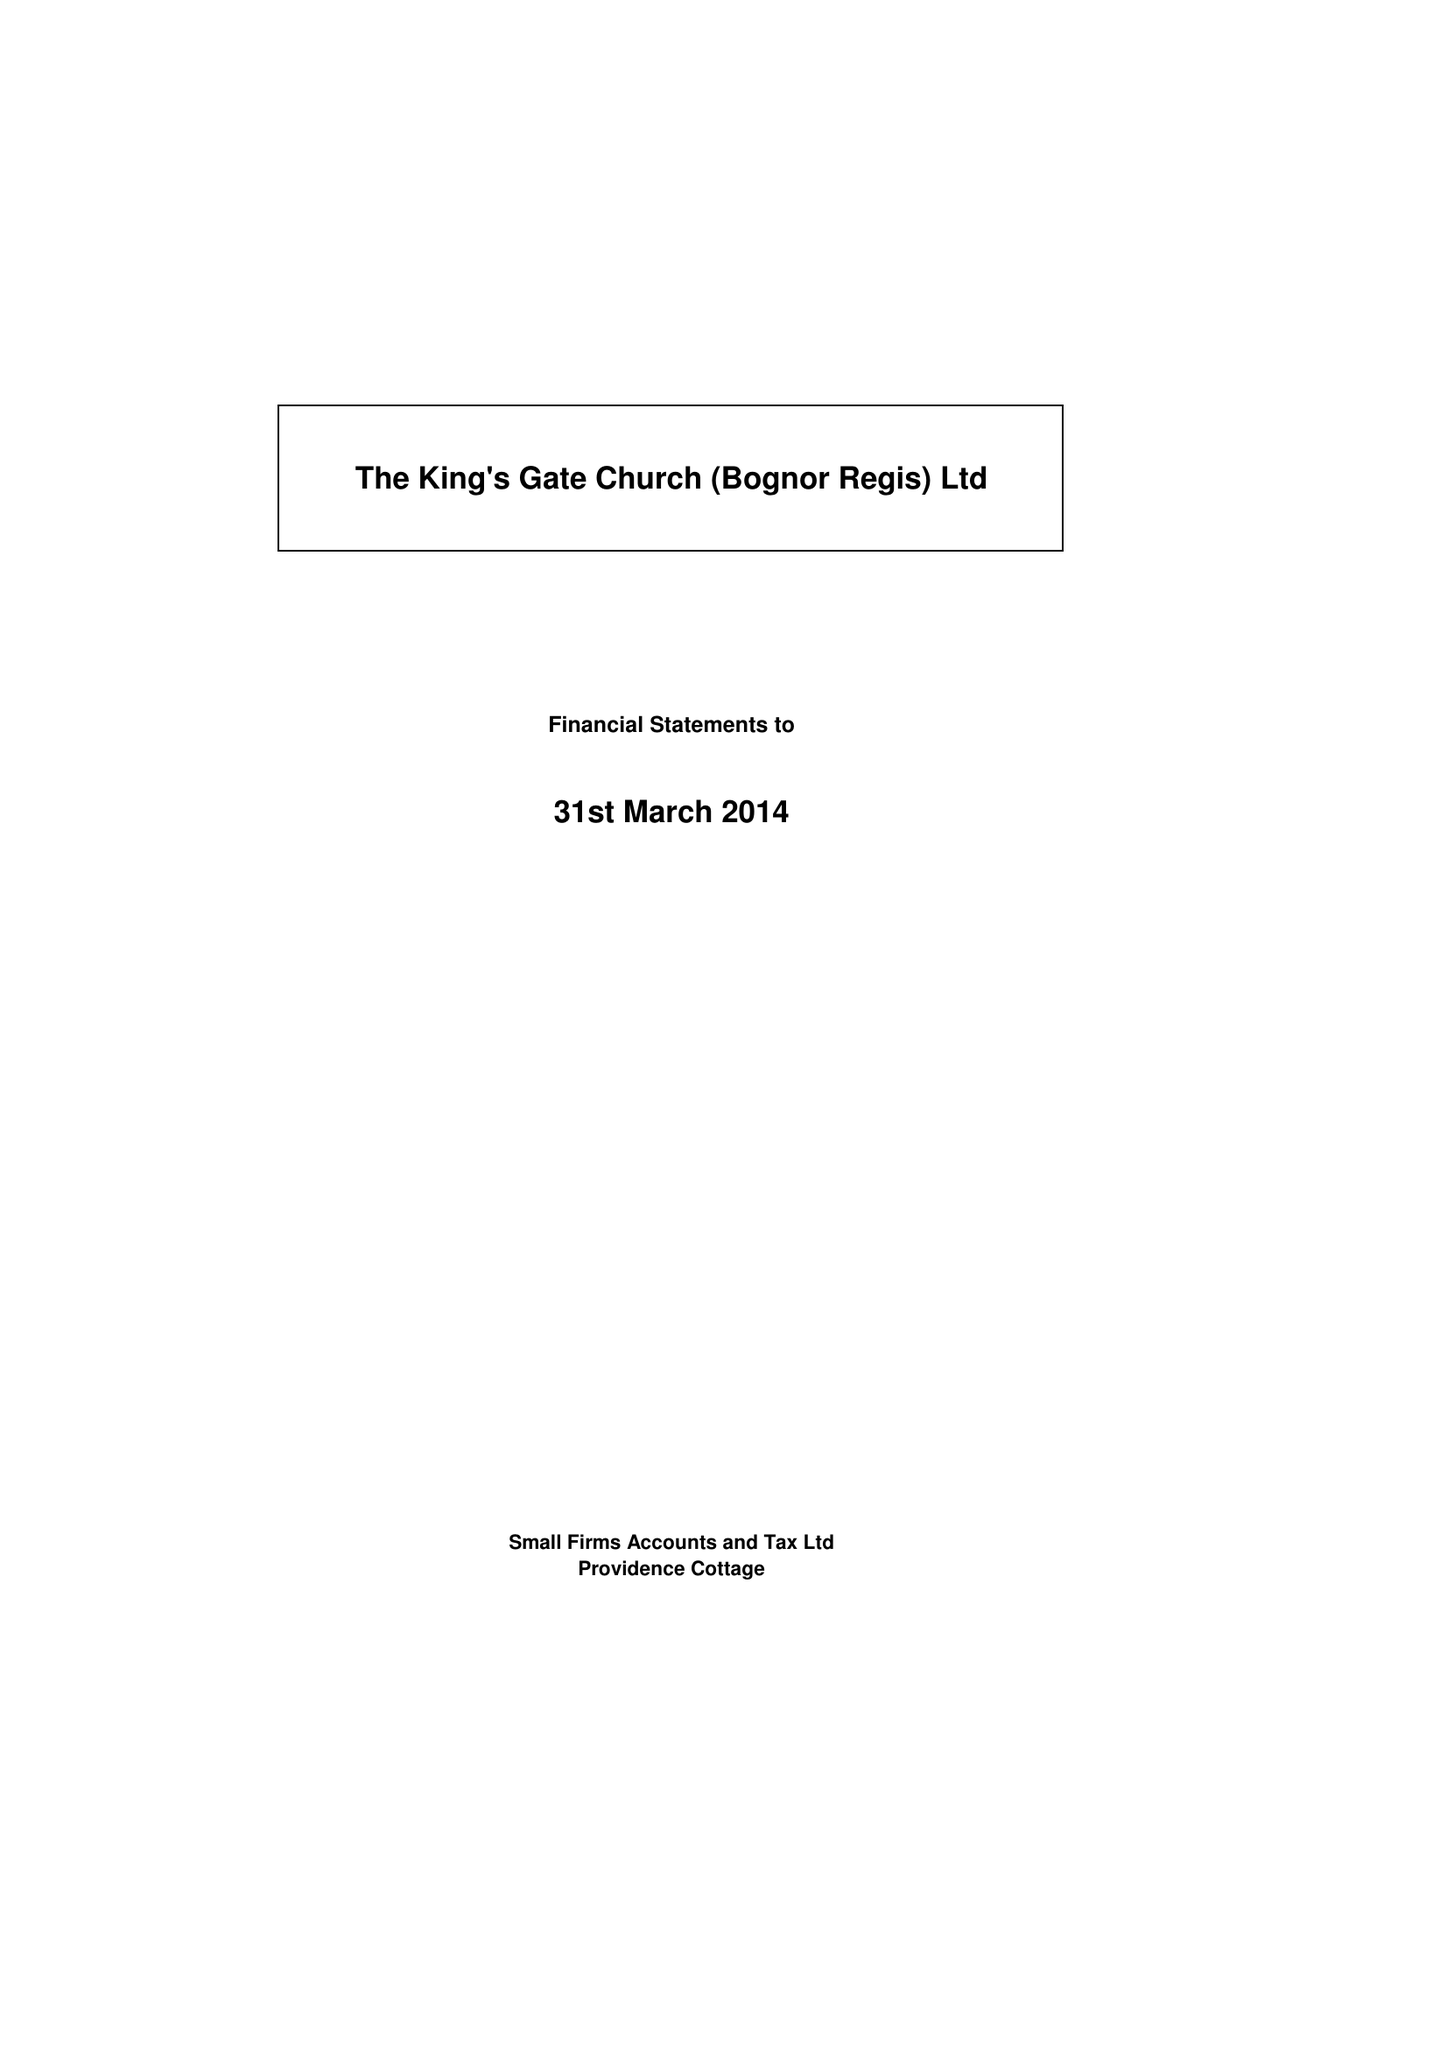What is the value for the income_annually_in_british_pounds?
Answer the question using a single word or phrase. 57593.00 